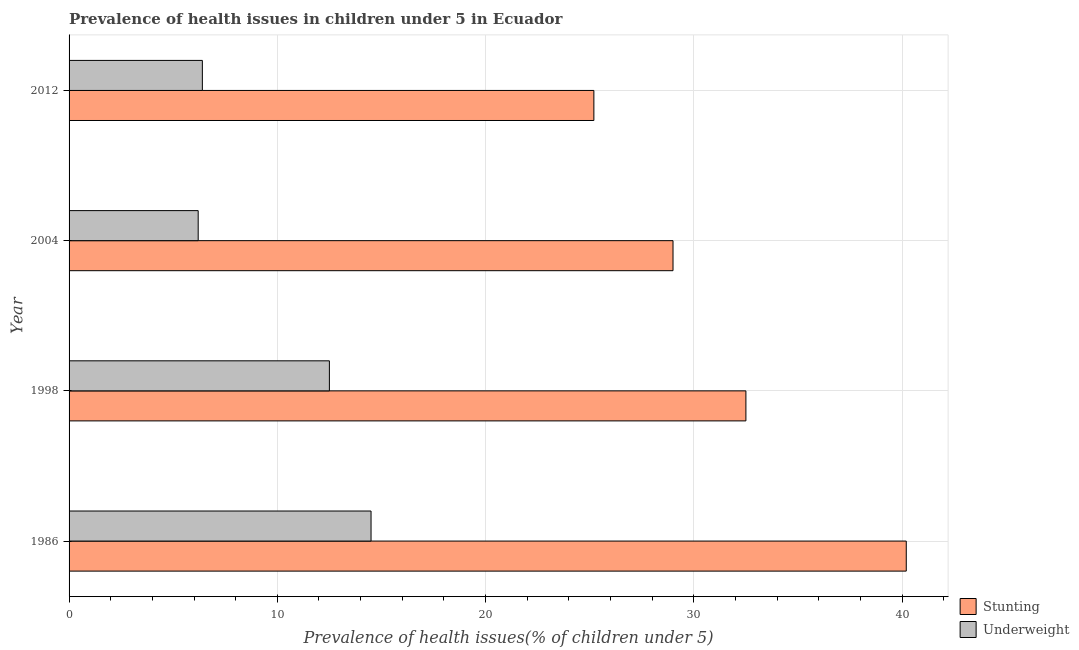How many groups of bars are there?
Keep it short and to the point. 4. Are the number of bars on each tick of the Y-axis equal?
Offer a terse response. Yes. How many bars are there on the 3rd tick from the top?
Your answer should be very brief. 2. How many bars are there on the 4th tick from the bottom?
Offer a terse response. 2. What is the label of the 2nd group of bars from the top?
Keep it short and to the point. 2004. In how many cases, is the number of bars for a given year not equal to the number of legend labels?
Make the answer very short. 0. What is the percentage of underweight children in 1998?
Offer a terse response. 12.5. Across all years, what is the maximum percentage of underweight children?
Provide a short and direct response. 14.5. Across all years, what is the minimum percentage of stunted children?
Keep it short and to the point. 25.2. In which year was the percentage of underweight children maximum?
Your answer should be compact. 1986. In which year was the percentage of stunted children minimum?
Make the answer very short. 2012. What is the total percentage of stunted children in the graph?
Give a very brief answer. 126.9. What is the difference between the percentage of underweight children in 1998 and the percentage of stunted children in 1986?
Give a very brief answer. -27.7. In how many years, is the percentage of underweight children greater than 4 %?
Keep it short and to the point. 4. What is the ratio of the percentage of stunted children in 1998 to that in 2012?
Give a very brief answer. 1.29. Is the difference between the percentage of underweight children in 1986 and 2004 greater than the difference between the percentage of stunted children in 1986 and 2004?
Ensure brevity in your answer.  No. In how many years, is the percentage of underweight children greater than the average percentage of underweight children taken over all years?
Give a very brief answer. 2. What does the 2nd bar from the top in 2012 represents?
Offer a very short reply. Stunting. What does the 2nd bar from the bottom in 2004 represents?
Offer a very short reply. Underweight. How many bars are there?
Ensure brevity in your answer.  8. Are all the bars in the graph horizontal?
Provide a short and direct response. Yes. How many years are there in the graph?
Provide a succinct answer. 4. What is the difference between two consecutive major ticks on the X-axis?
Make the answer very short. 10. Are the values on the major ticks of X-axis written in scientific E-notation?
Your response must be concise. No. Does the graph contain any zero values?
Offer a terse response. No. How many legend labels are there?
Ensure brevity in your answer.  2. What is the title of the graph?
Give a very brief answer. Prevalence of health issues in children under 5 in Ecuador. What is the label or title of the X-axis?
Ensure brevity in your answer.  Prevalence of health issues(% of children under 5). What is the Prevalence of health issues(% of children under 5) in Stunting in 1986?
Your response must be concise. 40.2. What is the Prevalence of health issues(% of children under 5) in Underweight in 1986?
Provide a succinct answer. 14.5. What is the Prevalence of health issues(% of children under 5) of Stunting in 1998?
Your answer should be very brief. 32.5. What is the Prevalence of health issues(% of children under 5) of Underweight in 1998?
Give a very brief answer. 12.5. What is the Prevalence of health issues(% of children under 5) in Stunting in 2004?
Provide a succinct answer. 29. What is the Prevalence of health issues(% of children under 5) of Underweight in 2004?
Provide a short and direct response. 6.2. What is the Prevalence of health issues(% of children under 5) in Stunting in 2012?
Provide a short and direct response. 25.2. What is the Prevalence of health issues(% of children under 5) in Underweight in 2012?
Ensure brevity in your answer.  6.4. Across all years, what is the maximum Prevalence of health issues(% of children under 5) in Stunting?
Your response must be concise. 40.2. Across all years, what is the minimum Prevalence of health issues(% of children under 5) of Stunting?
Offer a terse response. 25.2. Across all years, what is the minimum Prevalence of health issues(% of children under 5) of Underweight?
Ensure brevity in your answer.  6.2. What is the total Prevalence of health issues(% of children under 5) of Stunting in the graph?
Give a very brief answer. 126.9. What is the total Prevalence of health issues(% of children under 5) in Underweight in the graph?
Make the answer very short. 39.6. What is the difference between the Prevalence of health issues(% of children under 5) of Stunting in 1986 and that in 1998?
Keep it short and to the point. 7.7. What is the difference between the Prevalence of health issues(% of children under 5) in Underweight in 1986 and that in 1998?
Offer a terse response. 2. What is the difference between the Prevalence of health issues(% of children under 5) of Stunting in 1986 and that in 2004?
Make the answer very short. 11.2. What is the difference between the Prevalence of health issues(% of children under 5) of Underweight in 1986 and that in 2004?
Your response must be concise. 8.3. What is the difference between the Prevalence of health issues(% of children under 5) in Underweight in 1986 and that in 2012?
Provide a succinct answer. 8.1. What is the difference between the Prevalence of health issues(% of children under 5) in Stunting in 1998 and that in 2004?
Offer a very short reply. 3.5. What is the difference between the Prevalence of health issues(% of children under 5) in Stunting in 1986 and the Prevalence of health issues(% of children under 5) in Underweight in 1998?
Your answer should be very brief. 27.7. What is the difference between the Prevalence of health issues(% of children under 5) of Stunting in 1986 and the Prevalence of health issues(% of children under 5) of Underweight in 2004?
Your answer should be compact. 34. What is the difference between the Prevalence of health issues(% of children under 5) of Stunting in 1986 and the Prevalence of health issues(% of children under 5) of Underweight in 2012?
Give a very brief answer. 33.8. What is the difference between the Prevalence of health issues(% of children under 5) of Stunting in 1998 and the Prevalence of health issues(% of children under 5) of Underweight in 2004?
Provide a short and direct response. 26.3. What is the difference between the Prevalence of health issues(% of children under 5) of Stunting in 1998 and the Prevalence of health issues(% of children under 5) of Underweight in 2012?
Give a very brief answer. 26.1. What is the difference between the Prevalence of health issues(% of children under 5) of Stunting in 2004 and the Prevalence of health issues(% of children under 5) of Underweight in 2012?
Provide a succinct answer. 22.6. What is the average Prevalence of health issues(% of children under 5) of Stunting per year?
Your answer should be very brief. 31.73. What is the average Prevalence of health issues(% of children under 5) in Underweight per year?
Your answer should be very brief. 9.9. In the year 1986, what is the difference between the Prevalence of health issues(% of children under 5) of Stunting and Prevalence of health issues(% of children under 5) of Underweight?
Keep it short and to the point. 25.7. In the year 2004, what is the difference between the Prevalence of health issues(% of children under 5) of Stunting and Prevalence of health issues(% of children under 5) of Underweight?
Keep it short and to the point. 22.8. What is the ratio of the Prevalence of health issues(% of children under 5) of Stunting in 1986 to that in 1998?
Your answer should be compact. 1.24. What is the ratio of the Prevalence of health issues(% of children under 5) of Underweight in 1986 to that in 1998?
Make the answer very short. 1.16. What is the ratio of the Prevalence of health issues(% of children under 5) of Stunting in 1986 to that in 2004?
Give a very brief answer. 1.39. What is the ratio of the Prevalence of health issues(% of children under 5) in Underweight in 1986 to that in 2004?
Ensure brevity in your answer.  2.34. What is the ratio of the Prevalence of health issues(% of children under 5) of Stunting in 1986 to that in 2012?
Provide a short and direct response. 1.6. What is the ratio of the Prevalence of health issues(% of children under 5) in Underweight in 1986 to that in 2012?
Your answer should be very brief. 2.27. What is the ratio of the Prevalence of health issues(% of children under 5) of Stunting in 1998 to that in 2004?
Your answer should be compact. 1.12. What is the ratio of the Prevalence of health issues(% of children under 5) of Underweight in 1998 to that in 2004?
Provide a short and direct response. 2.02. What is the ratio of the Prevalence of health issues(% of children under 5) of Stunting in 1998 to that in 2012?
Offer a terse response. 1.29. What is the ratio of the Prevalence of health issues(% of children under 5) in Underweight in 1998 to that in 2012?
Keep it short and to the point. 1.95. What is the ratio of the Prevalence of health issues(% of children under 5) of Stunting in 2004 to that in 2012?
Provide a succinct answer. 1.15. What is the ratio of the Prevalence of health issues(% of children under 5) in Underweight in 2004 to that in 2012?
Provide a short and direct response. 0.97. What is the difference between the highest and the second highest Prevalence of health issues(% of children under 5) in Underweight?
Offer a very short reply. 2. What is the difference between the highest and the lowest Prevalence of health issues(% of children under 5) in Underweight?
Give a very brief answer. 8.3. 